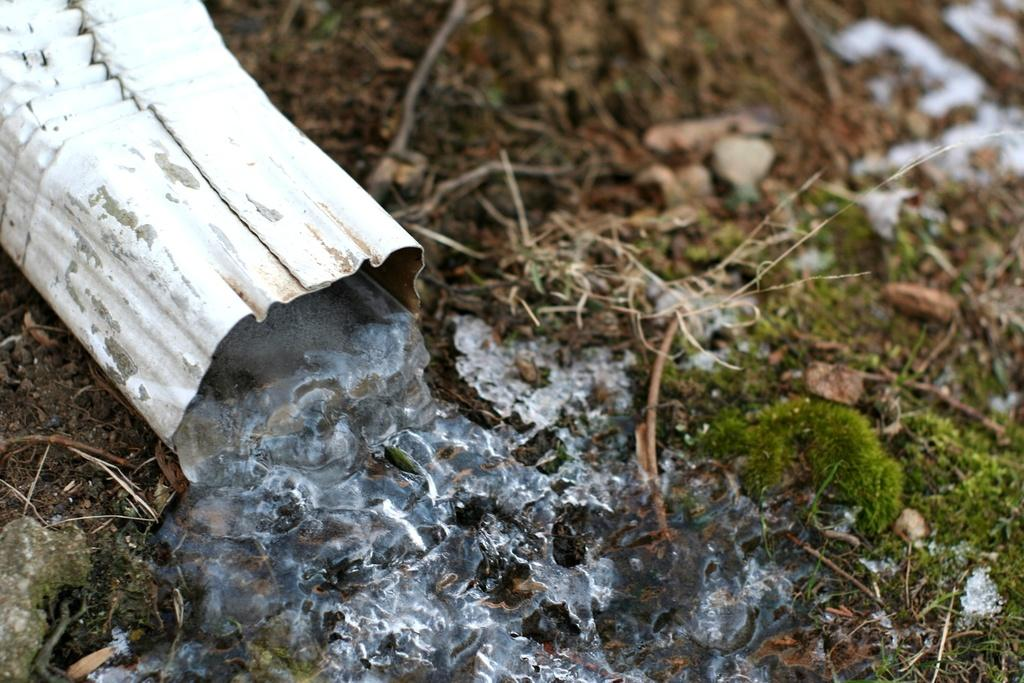What type of surface is visible at the bottom of the image? There is grass on the ground at the bottom of the image. What object is located at the top left of the image? There is a white tube at the top left of the image. What is coming out of the white tube? Ice is coming out of the white tube. What type of relation can be seen between the grass and the ice in the image? There is no relation between the grass and the ice in the image; they are separate elements in the scene. How many teeth are visible in the image? There are no teeth visible in the image. 